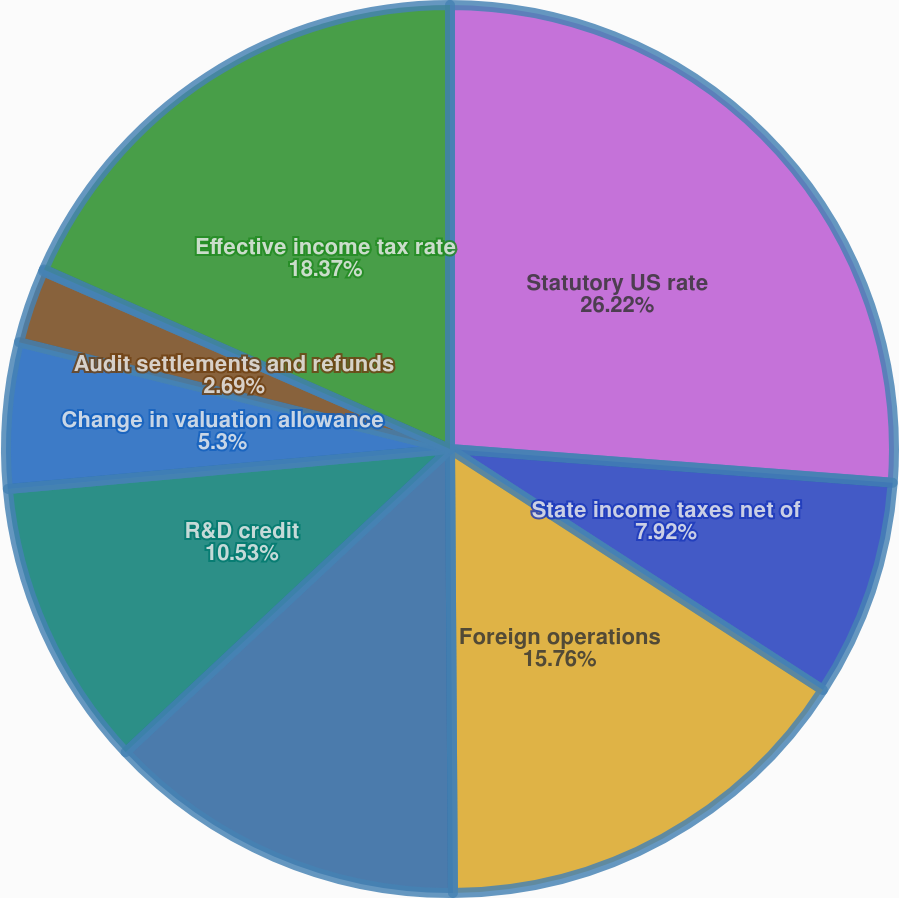Convert chart to OTSL. <chart><loc_0><loc_0><loc_500><loc_500><pie_chart><fcel>Statutory US rate<fcel>State income taxes net of<fcel>Foreign operations<fcel>Domestic manufacturing<fcel>R&D credit<fcel>Change in valuation allowance<fcel>Audit settlements and refunds<fcel>Other net<fcel>Effective income tax rate<nl><fcel>26.21%<fcel>7.92%<fcel>15.76%<fcel>13.14%<fcel>10.53%<fcel>5.3%<fcel>2.69%<fcel>0.07%<fcel>18.37%<nl></chart> 